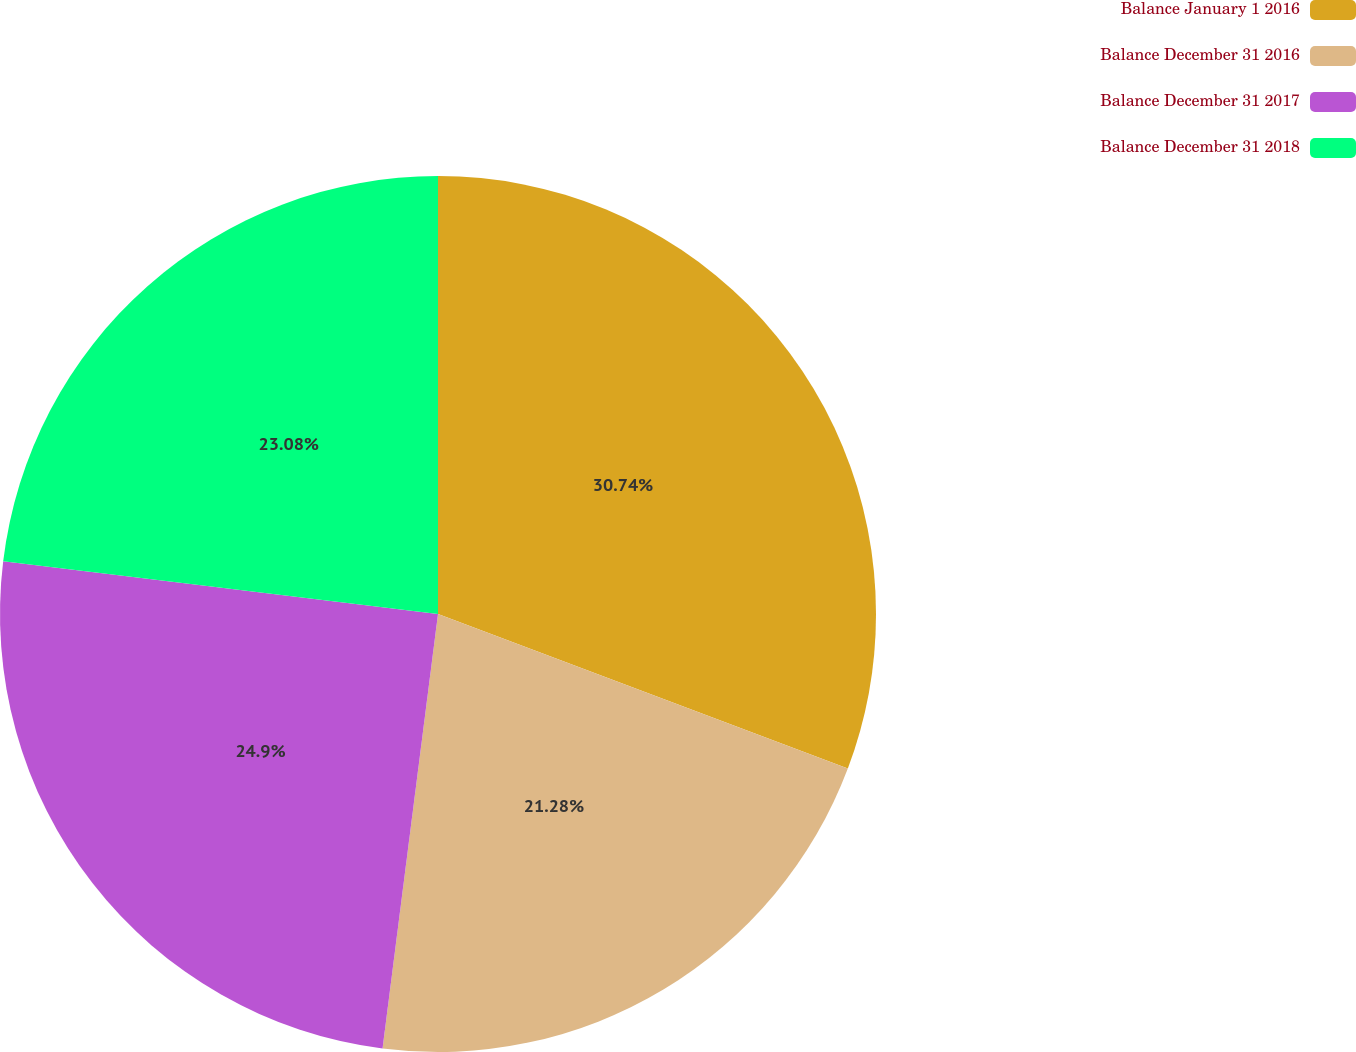<chart> <loc_0><loc_0><loc_500><loc_500><pie_chart><fcel>Balance January 1 2016<fcel>Balance December 31 2016<fcel>Balance December 31 2017<fcel>Balance December 31 2018<nl><fcel>30.74%<fcel>21.28%<fcel>24.9%<fcel>23.08%<nl></chart> 